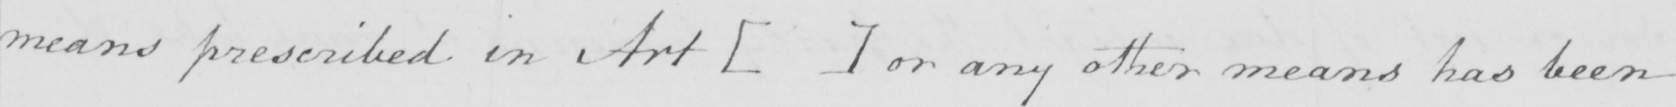Please transcribe the handwritten text in this image. means prescribed in Art  [   ]  or any other means has been 